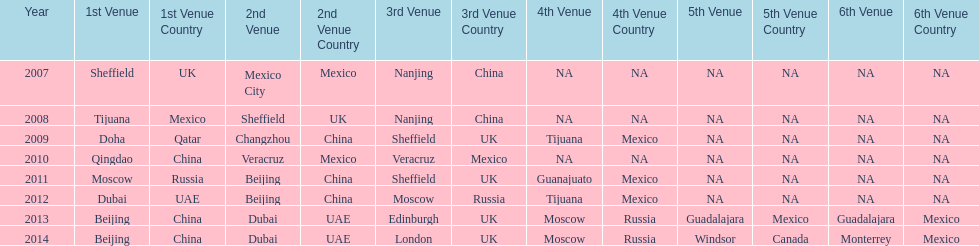Which two venue has no nations from 2007-2012 5th Venue, 6th Venue. 